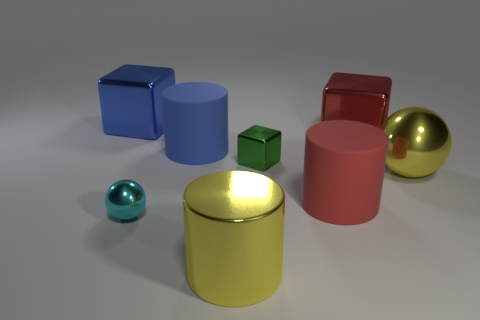How many red things are either rubber objects or large metal balls?
Provide a short and direct response. 1. How big is the blue object right of the big cube to the left of the big cylinder behind the big sphere?
Your response must be concise. Large. There is a green object that is the same shape as the big red metal object; what size is it?
Keep it short and to the point. Small. How many large objects are cylinders or green metallic things?
Give a very brief answer. 3. Are the cylinder right of the yellow metallic cylinder and the big object left of the large blue cylinder made of the same material?
Your answer should be compact. No. There is a big block that is to the left of the red cylinder; what is its material?
Give a very brief answer. Metal. How many metallic things are large blocks or green things?
Give a very brief answer. 3. There is a small shiny object on the right side of the metal ball to the left of the big blue matte thing; what color is it?
Keep it short and to the point. Green. Are the green block and the ball that is to the right of the small green shiny object made of the same material?
Provide a short and direct response. Yes. There is a block to the left of the big yellow metal object left of the big block to the right of the tiny cube; what is its color?
Give a very brief answer. Blue. 